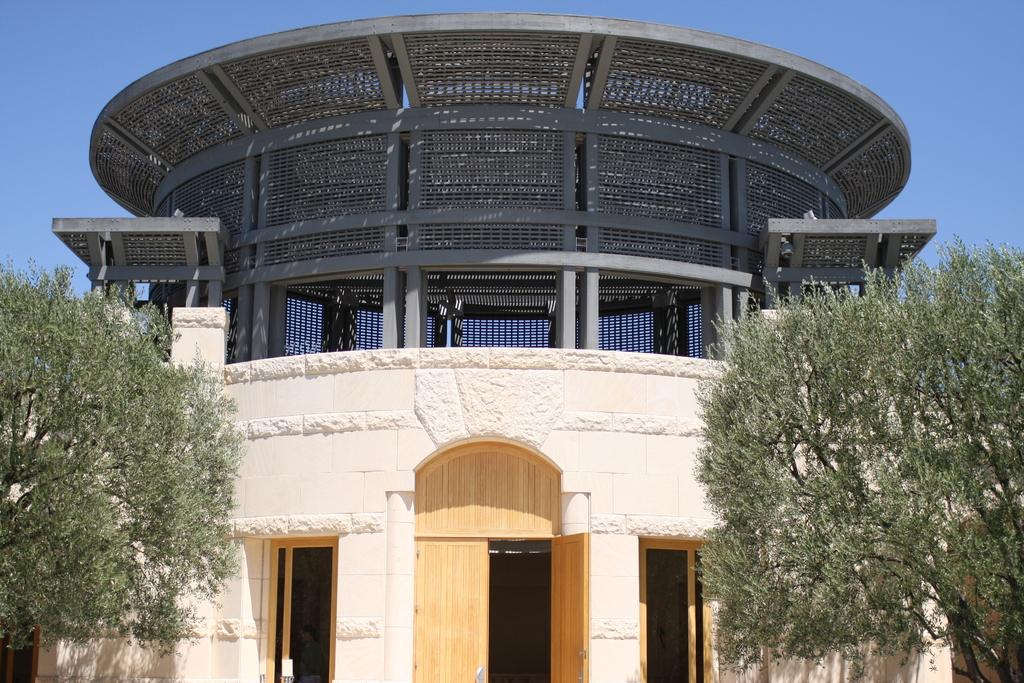What type of structure is present in the image? There is a building in the image. What type of vegetation can be seen in the image? There are two trees in the image. What is visible at the top of the image? The sky is visible at the top of the image. What is your opinion on the month depicted in the image? The image does not depict a specific month, so it is not possible to provide an opinion on the month. 